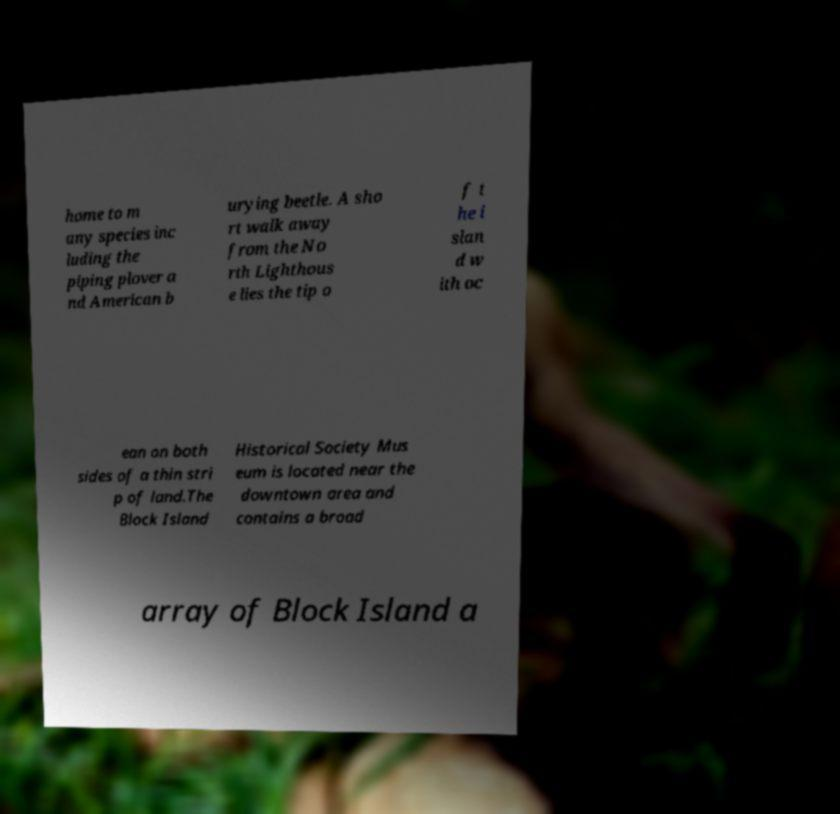Please identify and transcribe the text found in this image. home to m any species inc luding the piping plover a nd American b urying beetle. A sho rt walk away from the No rth Lighthous e lies the tip o f t he i slan d w ith oc ean on both sides of a thin stri p of land.The Block Island Historical Society Mus eum is located near the downtown area and contains a broad array of Block Island a 